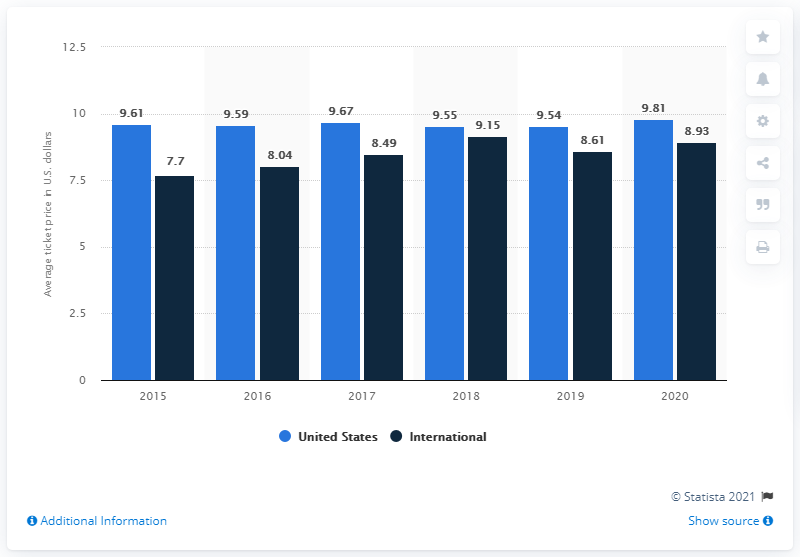Outline some significant characteristics in this image. In 2020, the average international ticket price for a movie at AMC Theatres was approximately $8.93. In 2020, the average ticket price in the United States was 9.81 dollars. 